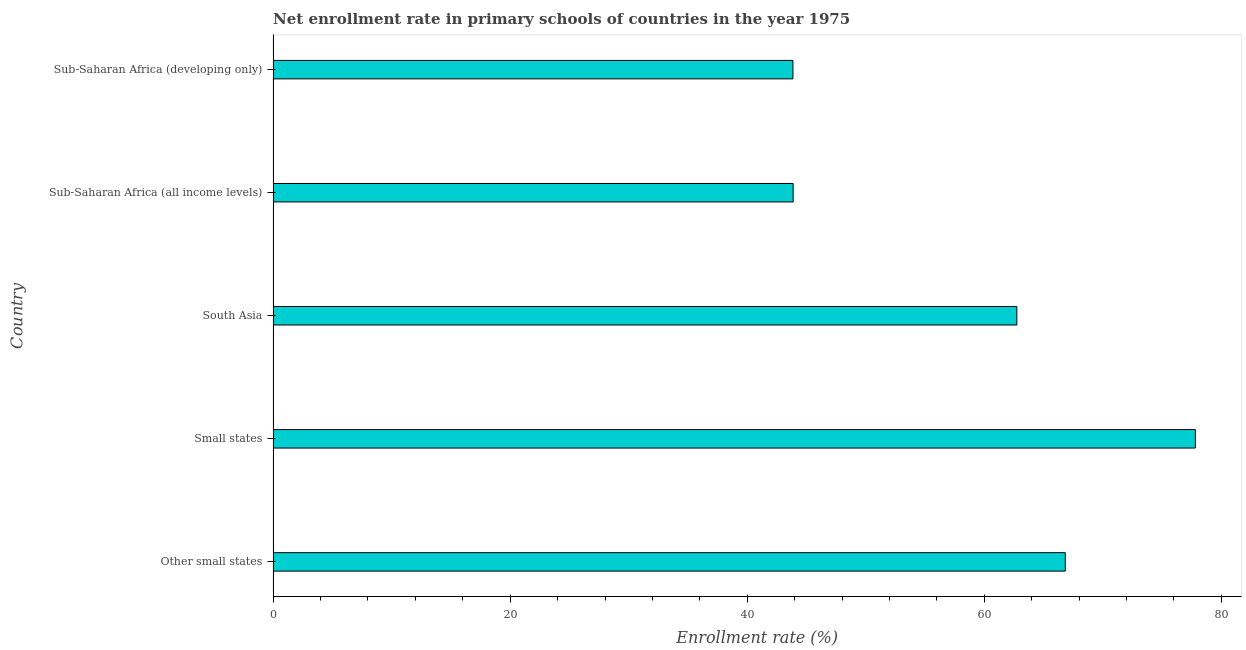Does the graph contain any zero values?
Offer a terse response. No. What is the title of the graph?
Provide a short and direct response. Net enrollment rate in primary schools of countries in the year 1975. What is the label or title of the X-axis?
Offer a terse response. Enrollment rate (%). What is the label or title of the Y-axis?
Your answer should be very brief. Country. What is the net enrollment rate in primary schools in Sub-Saharan Africa (all income levels)?
Your answer should be compact. 43.87. Across all countries, what is the maximum net enrollment rate in primary schools?
Your response must be concise. 77.81. Across all countries, what is the minimum net enrollment rate in primary schools?
Offer a very short reply. 43.85. In which country was the net enrollment rate in primary schools maximum?
Give a very brief answer. Small states. In which country was the net enrollment rate in primary schools minimum?
Make the answer very short. Sub-Saharan Africa (developing only). What is the sum of the net enrollment rate in primary schools?
Give a very brief answer. 295.1. What is the difference between the net enrollment rate in primary schools in Sub-Saharan Africa (all income levels) and Sub-Saharan Africa (developing only)?
Your answer should be compact. 0.02. What is the average net enrollment rate in primary schools per country?
Keep it short and to the point. 59.02. What is the median net enrollment rate in primary schools?
Your response must be concise. 62.74. What is the ratio of the net enrollment rate in primary schools in Other small states to that in Sub-Saharan Africa (all income levels)?
Ensure brevity in your answer.  1.52. Is the net enrollment rate in primary schools in Sub-Saharan Africa (all income levels) less than that in Sub-Saharan Africa (developing only)?
Offer a very short reply. No. What is the difference between the highest and the second highest net enrollment rate in primary schools?
Offer a terse response. 10.97. What is the difference between the highest and the lowest net enrollment rate in primary schools?
Provide a short and direct response. 33.95. In how many countries, is the net enrollment rate in primary schools greater than the average net enrollment rate in primary schools taken over all countries?
Make the answer very short. 3. How many countries are there in the graph?
Make the answer very short. 5. Are the values on the major ticks of X-axis written in scientific E-notation?
Your response must be concise. No. What is the Enrollment rate (%) of Other small states?
Provide a succinct answer. 66.83. What is the Enrollment rate (%) of Small states?
Ensure brevity in your answer.  77.81. What is the Enrollment rate (%) of South Asia?
Offer a terse response. 62.74. What is the Enrollment rate (%) of Sub-Saharan Africa (all income levels)?
Offer a terse response. 43.87. What is the Enrollment rate (%) in Sub-Saharan Africa (developing only)?
Offer a very short reply. 43.85. What is the difference between the Enrollment rate (%) in Other small states and Small states?
Your response must be concise. -10.98. What is the difference between the Enrollment rate (%) in Other small states and South Asia?
Provide a succinct answer. 4.09. What is the difference between the Enrollment rate (%) in Other small states and Sub-Saharan Africa (all income levels)?
Offer a very short reply. 22.96. What is the difference between the Enrollment rate (%) in Other small states and Sub-Saharan Africa (developing only)?
Offer a terse response. 22.98. What is the difference between the Enrollment rate (%) in Small states and South Asia?
Give a very brief answer. 15.06. What is the difference between the Enrollment rate (%) in Small states and Sub-Saharan Africa (all income levels)?
Make the answer very short. 33.94. What is the difference between the Enrollment rate (%) in Small states and Sub-Saharan Africa (developing only)?
Keep it short and to the point. 33.95. What is the difference between the Enrollment rate (%) in South Asia and Sub-Saharan Africa (all income levels)?
Offer a very short reply. 18.87. What is the difference between the Enrollment rate (%) in South Asia and Sub-Saharan Africa (developing only)?
Your answer should be compact. 18.89. What is the difference between the Enrollment rate (%) in Sub-Saharan Africa (all income levels) and Sub-Saharan Africa (developing only)?
Make the answer very short. 0.02. What is the ratio of the Enrollment rate (%) in Other small states to that in Small states?
Give a very brief answer. 0.86. What is the ratio of the Enrollment rate (%) in Other small states to that in South Asia?
Offer a terse response. 1.06. What is the ratio of the Enrollment rate (%) in Other small states to that in Sub-Saharan Africa (all income levels)?
Your response must be concise. 1.52. What is the ratio of the Enrollment rate (%) in Other small states to that in Sub-Saharan Africa (developing only)?
Provide a short and direct response. 1.52. What is the ratio of the Enrollment rate (%) in Small states to that in South Asia?
Your answer should be very brief. 1.24. What is the ratio of the Enrollment rate (%) in Small states to that in Sub-Saharan Africa (all income levels)?
Offer a terse response. 1.77. What is the ratio of the Enrollment rate (%) in Small states to that in Sub-Saharan Africa (developing only)?
Offer a very short reply. 1.77. What is the ratio of the Enrollment rate (%) in South Asia to that in Sub-Saharan Africa (all income levels)?
Your response must be concise. 1.43. What is the ratio of the Enrollment rate (%) in South Asia to that in Sub-Saharan Africa (developing only)?
Make the answer very short. 1.43. What is the ratio of the Enrollment rate (%) in Sub-Saharan Africa (all income levels) to that in Sub-Saharan Africa (developing only)?
Keep it short and to the point. 1. 